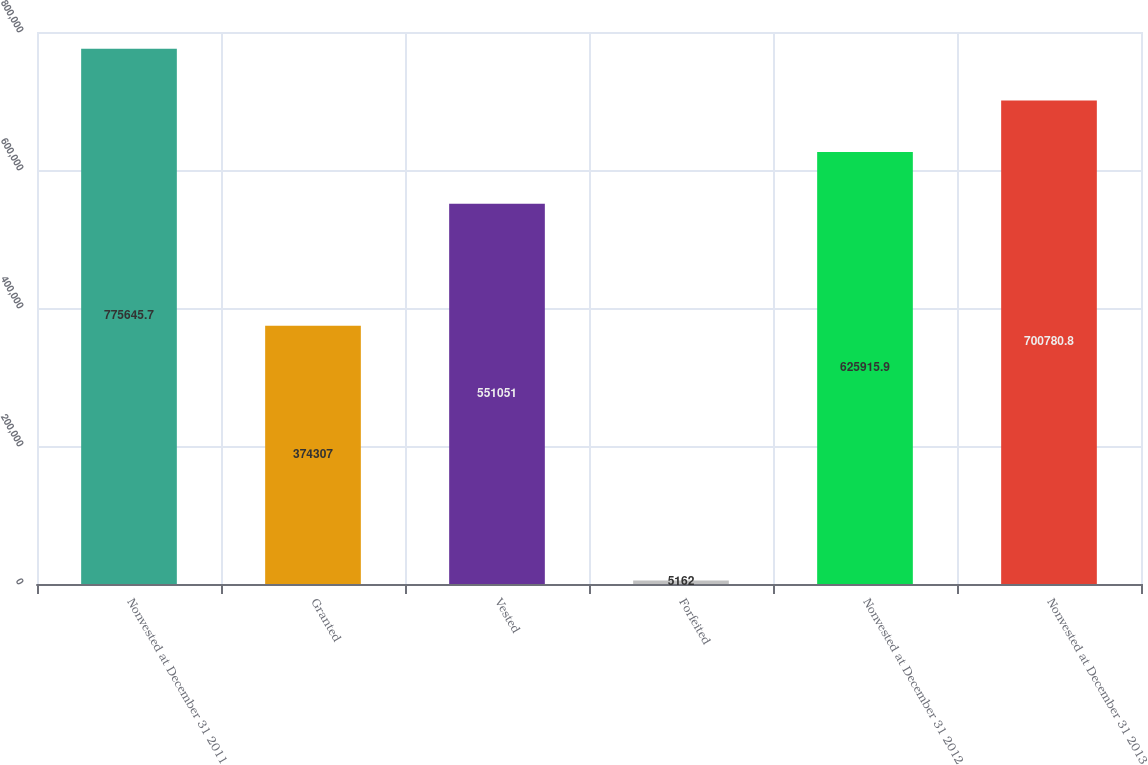Convert chart. <chart><loc_0><loc_0><loc_500><loc_500><bar_chart><fcel>Nonvested at December 31 2011<fcel>Granted<fcel>Vested<fcel>Forfeited<fcel>Nonvested at December 31 2012<fcel>Nonvested at December 31 2013<nl><fcel>775646<fcel>374307<fcel>551051<fcel>5162<fcel>625916<fcel>700781<nl></chart> 